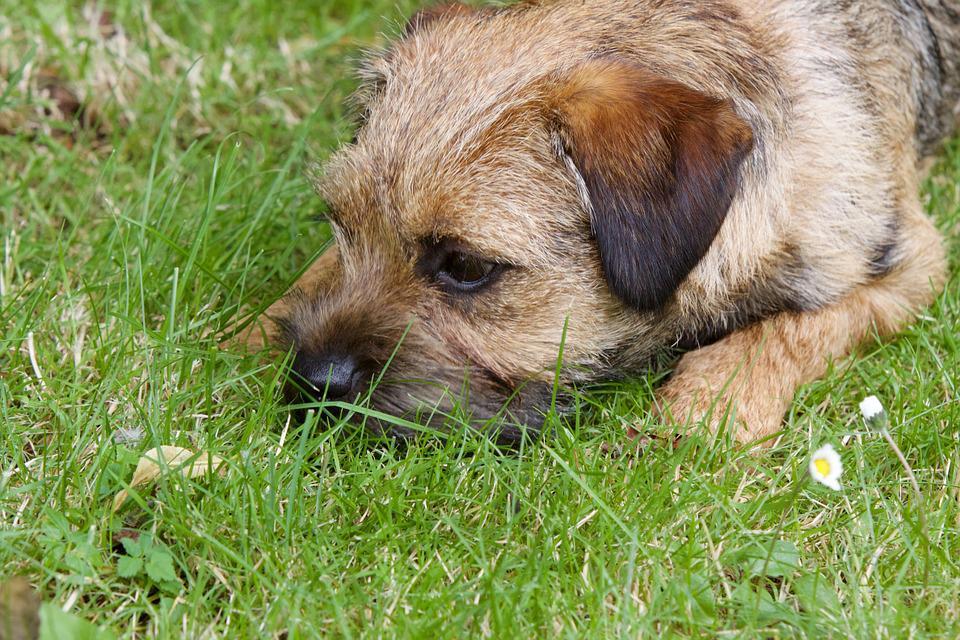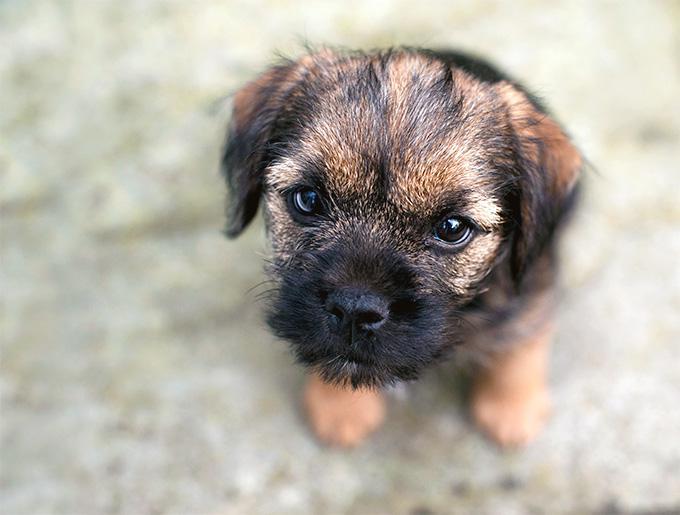The first image is the image on the left, the second image is the image on the right. For the images displayed, is the sentence "Right image shows puppy standing on grass with one paw raised." factually correct? Answer yes or no. No. The first image is the image on the left, the second image is the image on the right. For the images displayed, is the sentence "Two small dogs with floppy ears are in green grassy areas." factually correct? Answer yes or no. No. 